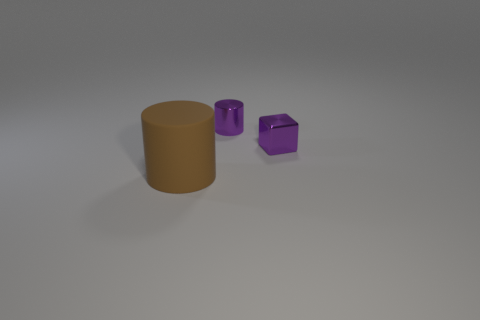Add 3 brown rubber objects. How many objects exist? 6 Subtract 1 cylinders. How many cylinders are left? 1 Subtract all yellow cubes. How many purple cylinders are left? 1 Subtract all purple metal objects. Subtract all big cylinders. How many objects are left? 0 Add 2 brown rubber cylinders. How many brown rubber cylinders are left? 3 Add 1 shiny cubes. How many shiny cubes exist? 2 Subtract 1 purple cubes. How many objects are left? 2 Subtract all cylinders. How many objects are left? 1 Subtract all brown cylinders. Subtract all green balls. How many cylinders are left? 1 